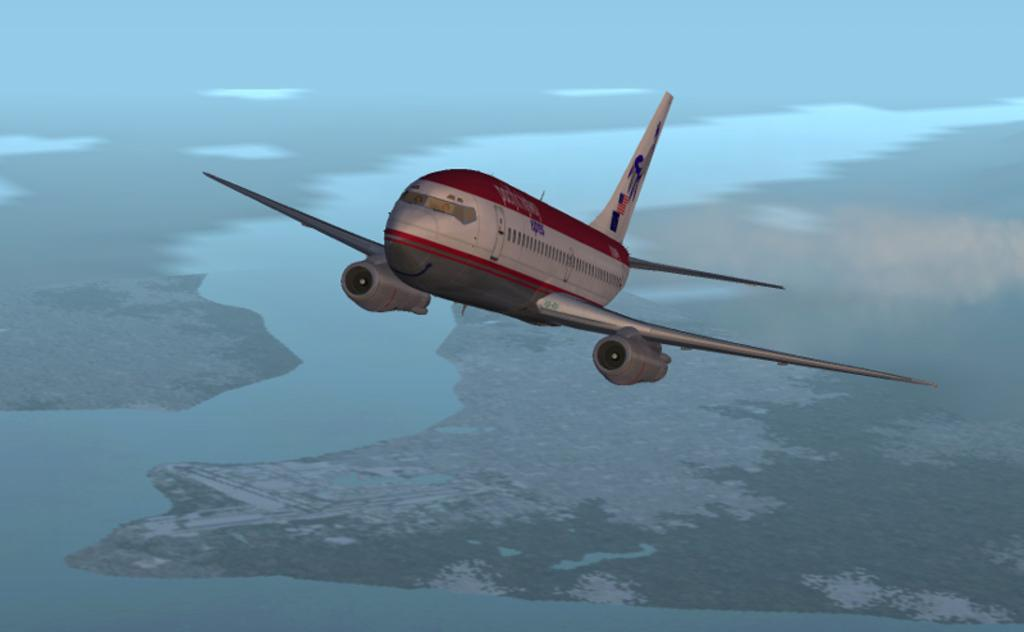What is happening in the air in the image? There is a flight flying in the air. What can be seen on the ground in the image? There is a lake on the ground. What is visible in the background of the image? The sky is visible. What type of flowers are growing near the lake in the image? There are no flowers mentioned or visible in the image; it only features a flight flying in the air and a lake on the ground. 